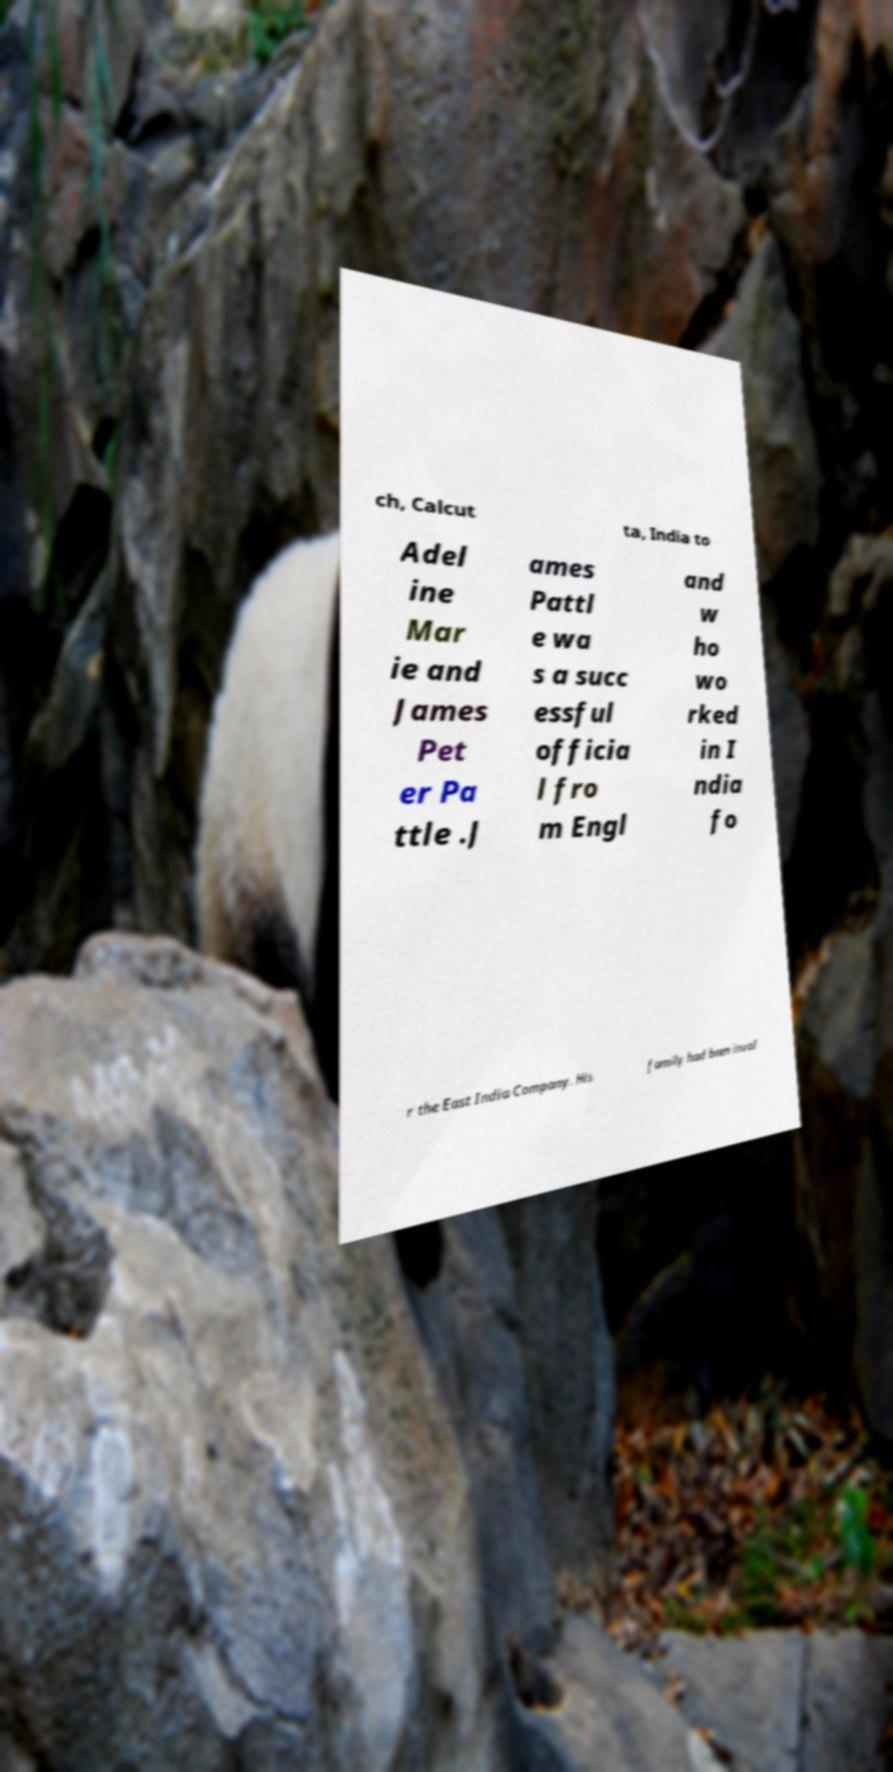Please read and relay the text visible in this image. What does it say? ch, Calcut ta, India to Adel ine Mar ie and James Pet er Pa ttle .J ames Pattl e wa s a succ essful officia l fro m Engl and w ho wo rked in I ndia fo r the East India Company. His family had been invol 